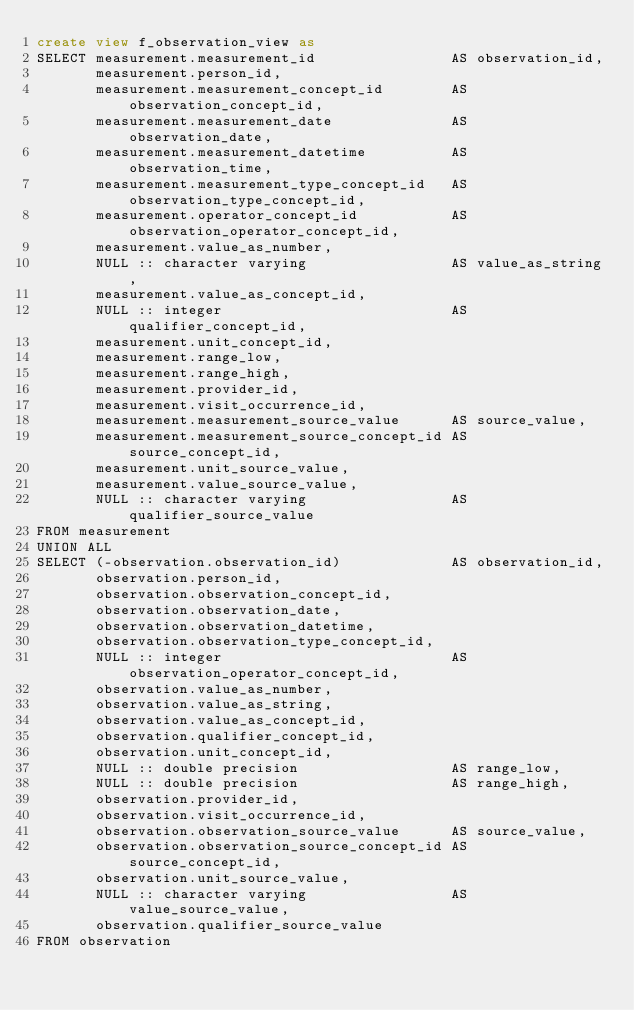Convert code to text. <code><loc_0><loc_0><loc_500><loc_500><_SQL_>create view f_observation_view as
SELECT measurement.measurement_id                AS observation_id,
       measurement.person_id,
       measurement.measurement_concept_id        AS observation_concept_id,
       measurement.measurement_date              AS observation_date,
       measurement.measurement_datetime          AS observation_time,
       measurement.measurement_type_concept_id   AS observation_type_concept_id,
       measurement.operator_concept_id           AS observation_operator_concept_id,
       measurement.value_as_number,
       NULL :: character varying                 AS value_as_string,
       measurement.value_as_concept_id,
       NULL :: integer                           AS qualifier_concept_id,
       measurement.unit_concept_id,
       measurement.range_low,
       measurement.range_high,
       measurement.provider_id,
       measurement.visit_occurrence_id,
       measurement.measurement_source_value      AS source_value,
       measurement.measurement_source_concept_id AS source_concept_id,
       measurement.unit_source_value,
       measurement.value_source_value,
       NULL :: character varying                 AS qualifier_source_value
FROM measurement
UNION ALL
SELECT (-observation.observation_id)             AS observation_id,
       observation.person_id,
       observation.observation_concept_id,
       observation.observation_date,
       observation.observation_datetime,
       observation.observation_type_concept_id,
       NULL :: integer                           AS observation_operator_concept_id,
       observation.value_as_number,
       observation.value_as_string,
       observation.value_as_concept_id,
       observation.qualifier_concept_id,
       observation.unit_concept_id,
       NULL :: double precision                  AS range_low,
       NULL :: double precision                  AS range_high,
       observation.provider_id,
       observation.visit_occurrence_id,
       observation.observation_source_value      AS source_value,
       observation.observation_source_concept_id AS source_concept_id,
       observation.unit_source_value,
       NULL :: character varying                 AS value_source_value,
       observation.qualifier_source_value
FROM observation</code> 